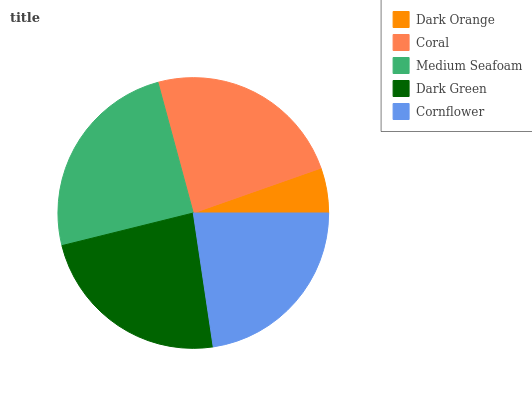Is Dark Orange the minimum?
Answer yes or no. Yes. Is Medium Seafoam the maximum?
Answer yes or no. Yes. Is Coral the minimum?
Answer yes or no. No. Is Coral the maximum?
Answer yes or no. No. Is Coral greater than Dark Orange?
Answer yes or no. Yes. Is Dark Orange less than Coral?
Answer yes or no. Yes. Is Dark Orange greater than Coral?
Answer yes or no. No. Is Coral less than Dark Orange?
Answer yes or no. No. Is Dark Green the high median?
Answer yes or no. Yes. Is Dark Green the low median?
Answer yes or no. Yes. Is Medium Seafoam the high median?
Answer yes or no. No. Is Dark Orange the low median?
Answer yes or no. No. 